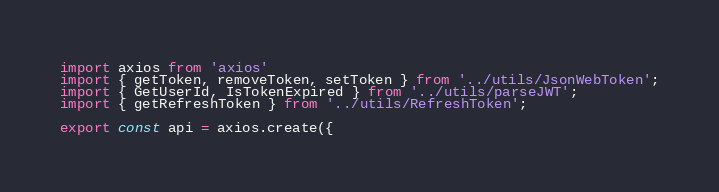<code> <loc_0><loc_0><loc_500><loc_500><_TypeScript_>import axios from 'axios'
import { getToken, removeToken, setToken } from '../utils/JsonWebToken';
import { GetUserId, IsTokenExpired } from '../utils/parseJWT';
import { getRefreshToken } from '../utils/RefreshToken';

export const api = axios.create({</code> 